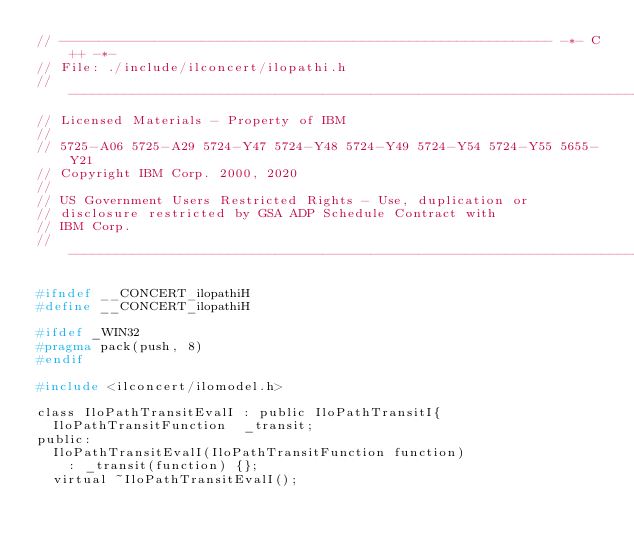Convert code to text. <code><loc_0><loc_0><loc_500><loc_500><_C_>// -------------------------------------------------------------- -*- C++ -*-
// File: ./include/ilconcert/ilopathi.h
// --------------------------------------------------------------------------
// Licensed Materials - Property of IBM
//
// 5725-A06 5725-A29 5724-Y47 5724-Y48 5724-Y49 5724-Y54 5724-Y55 5655-Y21
// Copyright IBM Corp. 2000, 2020
//
// US Government Users Restricted Rights - Use, duplication or
// disclosure restricted by GSA ADP Schedule Contract with
// IBM Corp.
// ---------------------------------------------------------------------------

#ifndef __CONCERT_ilopathiH
#define __CONCERT_ilopathiH

#ifdef _WIN32
#pragma pack(push, 8)
#endif

#include <ilconcert/ilomodel.h>

class IloPathTransitEvalI : public IloPathTransitI{
	IloPathTransitFunction  _transit;
public:
	IloPathTransitEvalI(IloPathTransitFunction function) 
		: _transit(function) {};
	virtual ~IloPathTransitEvalI();</code> 